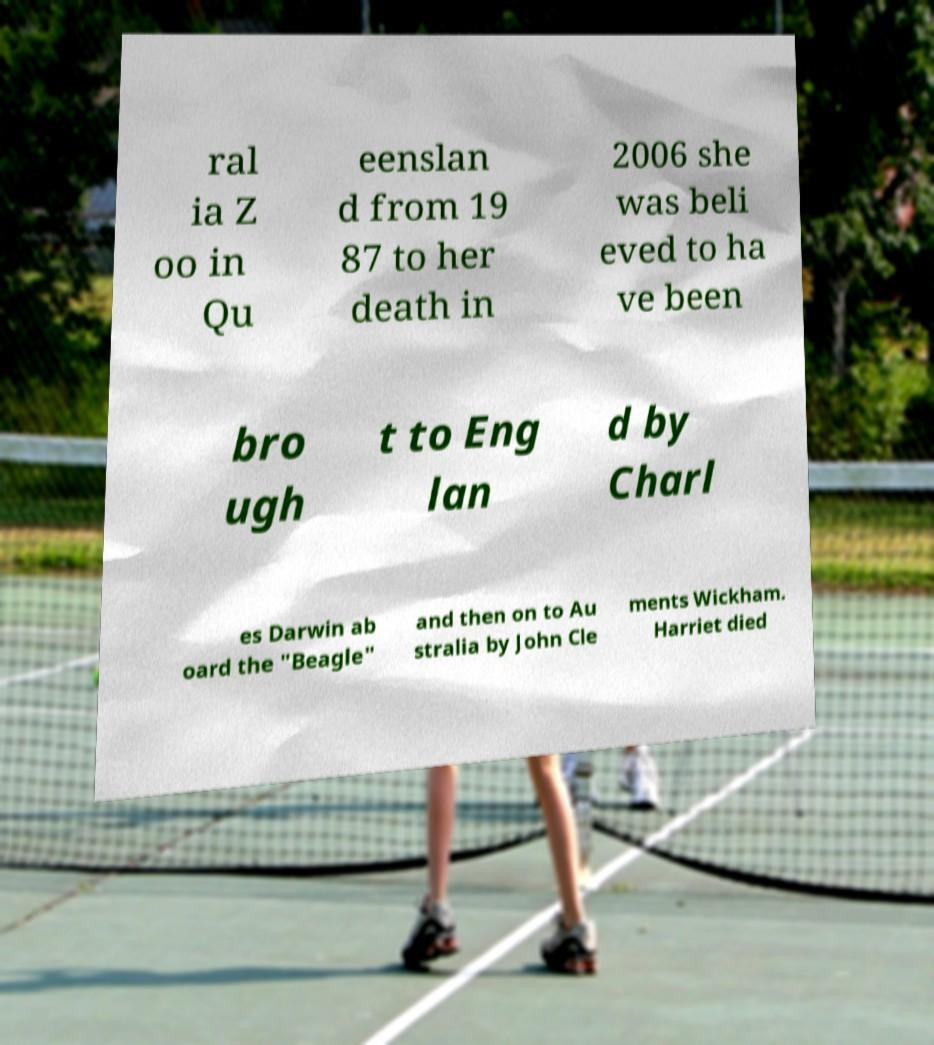Can you read and provide the text displayed in the image?This photo seems to have some interesting text. Can you extract and type it out for me? ral ia Z oo in Qu eenslan d from 19 87 to her death in 2006 she was beli eved to ha ve been bro ugh t to Eng lan d by Charl es Darwin ab oard the "Beagle" and then on to Au stralia by John Cle ments Wickham. Harriet died 